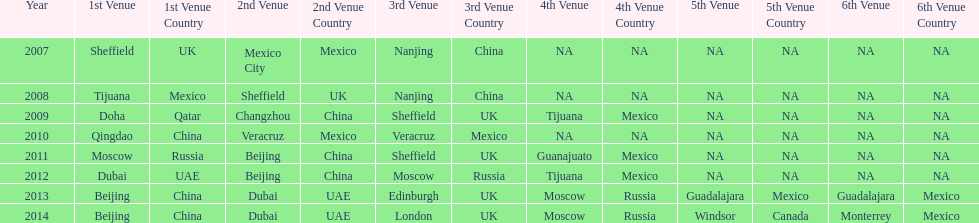Can you give me this table as a dict? {'header': ['Year', '1st Venue', '1st Venue Country', '2nd Venue', '2nd Venue Country', '3rd Venue', '3rd Venue Country', '4th Venue', '4th Venue Country', '5th Venue', '5th Venue Country', '6th Venue', '6th Venue Country'], 'rows': [['2007', 'Sheffield', 'UK', 'Mexico City', 'Mexico', 'Nanjing', 'China', 'NA', 'NA', 'NA', 'NA', 'NA', 'NA'], ['2008', 'Tijuana', 'Mexico', 'Sheffield', 'UK', 'Nanjing', 'China', 'NA', 'NA', 'NA', 'NA', 'NA', 'NA'], ['2009', 'Doha', 'Qatar', 'Changzhou', 'China', 'Sheffield', 'UK', 'Tijuana', 'Mexico', 'NA', 'NA', 'NA', 'NA'], ['2010', 'Qingdao', 'China', 'Veracruz', 'Mexico', 'Veracruz', 'Mexico', 'NA', 'NA', 'NA', 'NA', 'NA', 'NA'], ['2011', 'Moscow', 'Russia', 'Beijing', 'China', 'Sheffield', 'UK', 'Guanajuato', 'Mexico', 'NA', 'NA', 'NA', 'NA'], ['2012', 'Dubai', 'UAE', 'Beijing', 'China', 'Moscow', 'Russia', 'Tijuana', 'Mexico', 'NA', 'NA', 'NA', 'NA'], ['2013', 'Beijing', 'China', 'Dubai', 'UAE', 'Edinburgh', 'UK', 'Moscow', 'Russia', 'Guadalajara', 'Mexico', 'Guadalajara', 'Mexico'], ['2014', 'Beijing', 'China', 'Dubai', 'UAE', 'London', 'UK', 'Moscow', 'Russia', 'Windsor', 'Canada', 'Monterrey', 'Mexico']]} What was the last year where tijuana was a venue? 2012. 